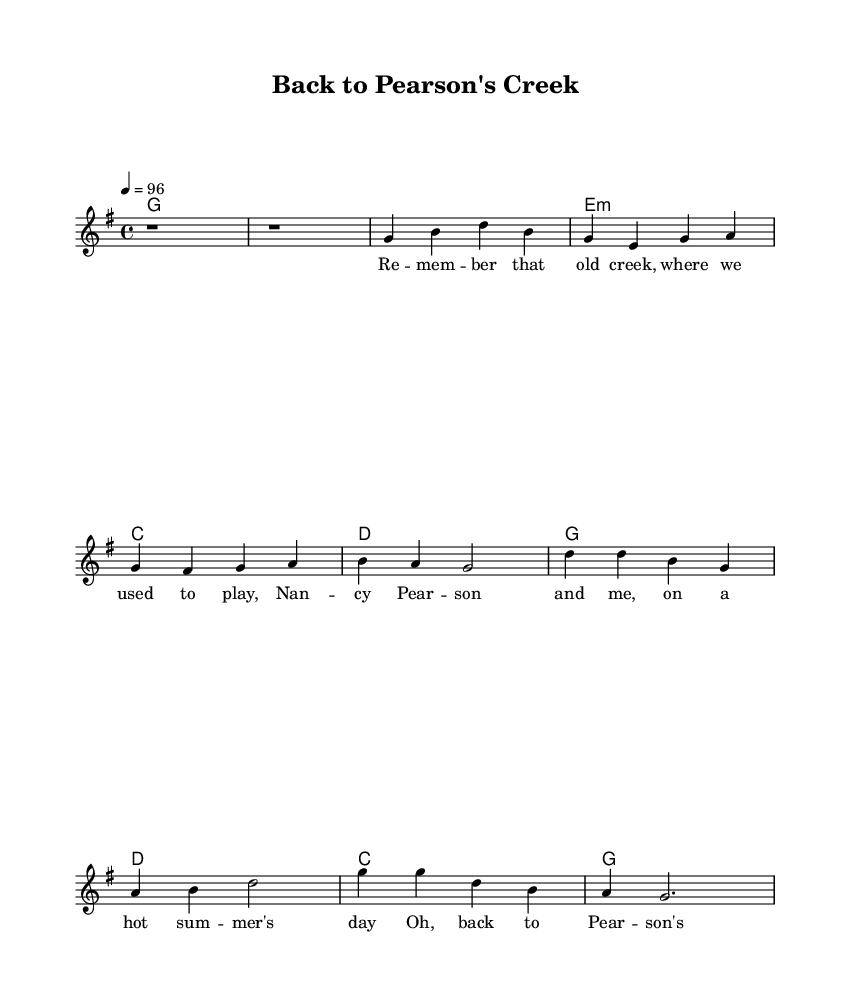What is the key signature of this music? The key signature is G major, which has one sharp (F#). We can determine this from the global section of the LilyPond code where it specifies `\key g \major`.
Answer: G major What is the time signature of this music? The time signature is 4/4, as indicated by the `\time 4/4` notation in the global section of the LilyPond code. This denotes four beats per measure.
Answer: 4/4 What is the tempo marking for this piece? The tempo is set to quarter note equals 96 beats per minute, indicated by `\tempo 4 = 96` in the global section. This tells the performer how fast to play the piece.
Answer: 96 How many measures are in the verse? There are four measures in the verse, as evidenced by the melody section where the verse notes are indicated. Counting them shows there are four distinct rhythmic groups.
Answer: Four Which chord follows the introduction? The chord following the introduction is G major, as seen in the harmonies section where the first chord after the introductory G is again `g1`.
Answer: G major What is the first line of the lyrics? The first line of the lyrics is "Remember that old creek, where we used to play," which can be found under the melody in the verseWords section.
Answer: Remember that old creek, where we used to play What theme does the chorus express? The chorus expresses a nostalgic theme about simpler times and cherished memories, as highlighted in the lyrics "Oh, back to Pearson's Creek, where the memories flow."
Answer: Nostalgia 